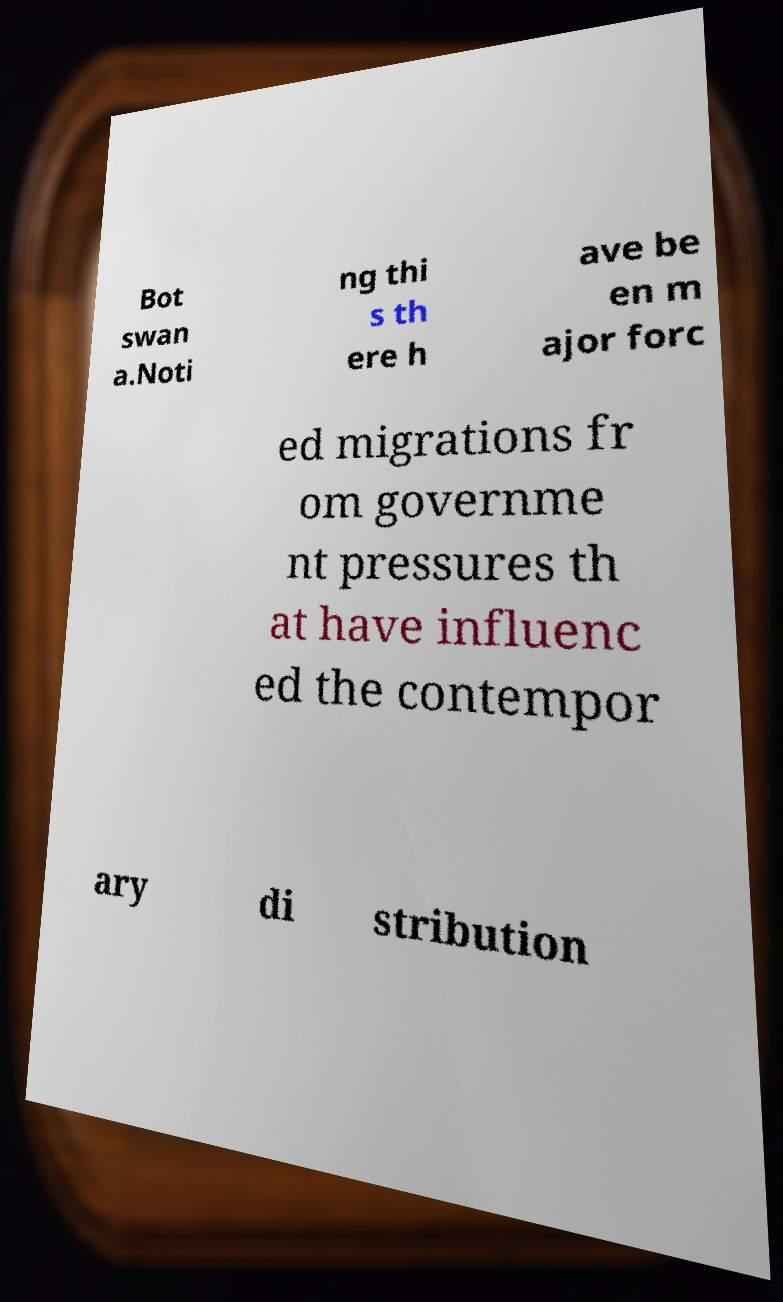Can you accurately transcribe the text from the provided image for me? Bot swan a.Noti ng thi s th ere h ave be en m ajor forc ed migrations fr om governme nt pressures th at have influenc ed the contempor ary di stribution 